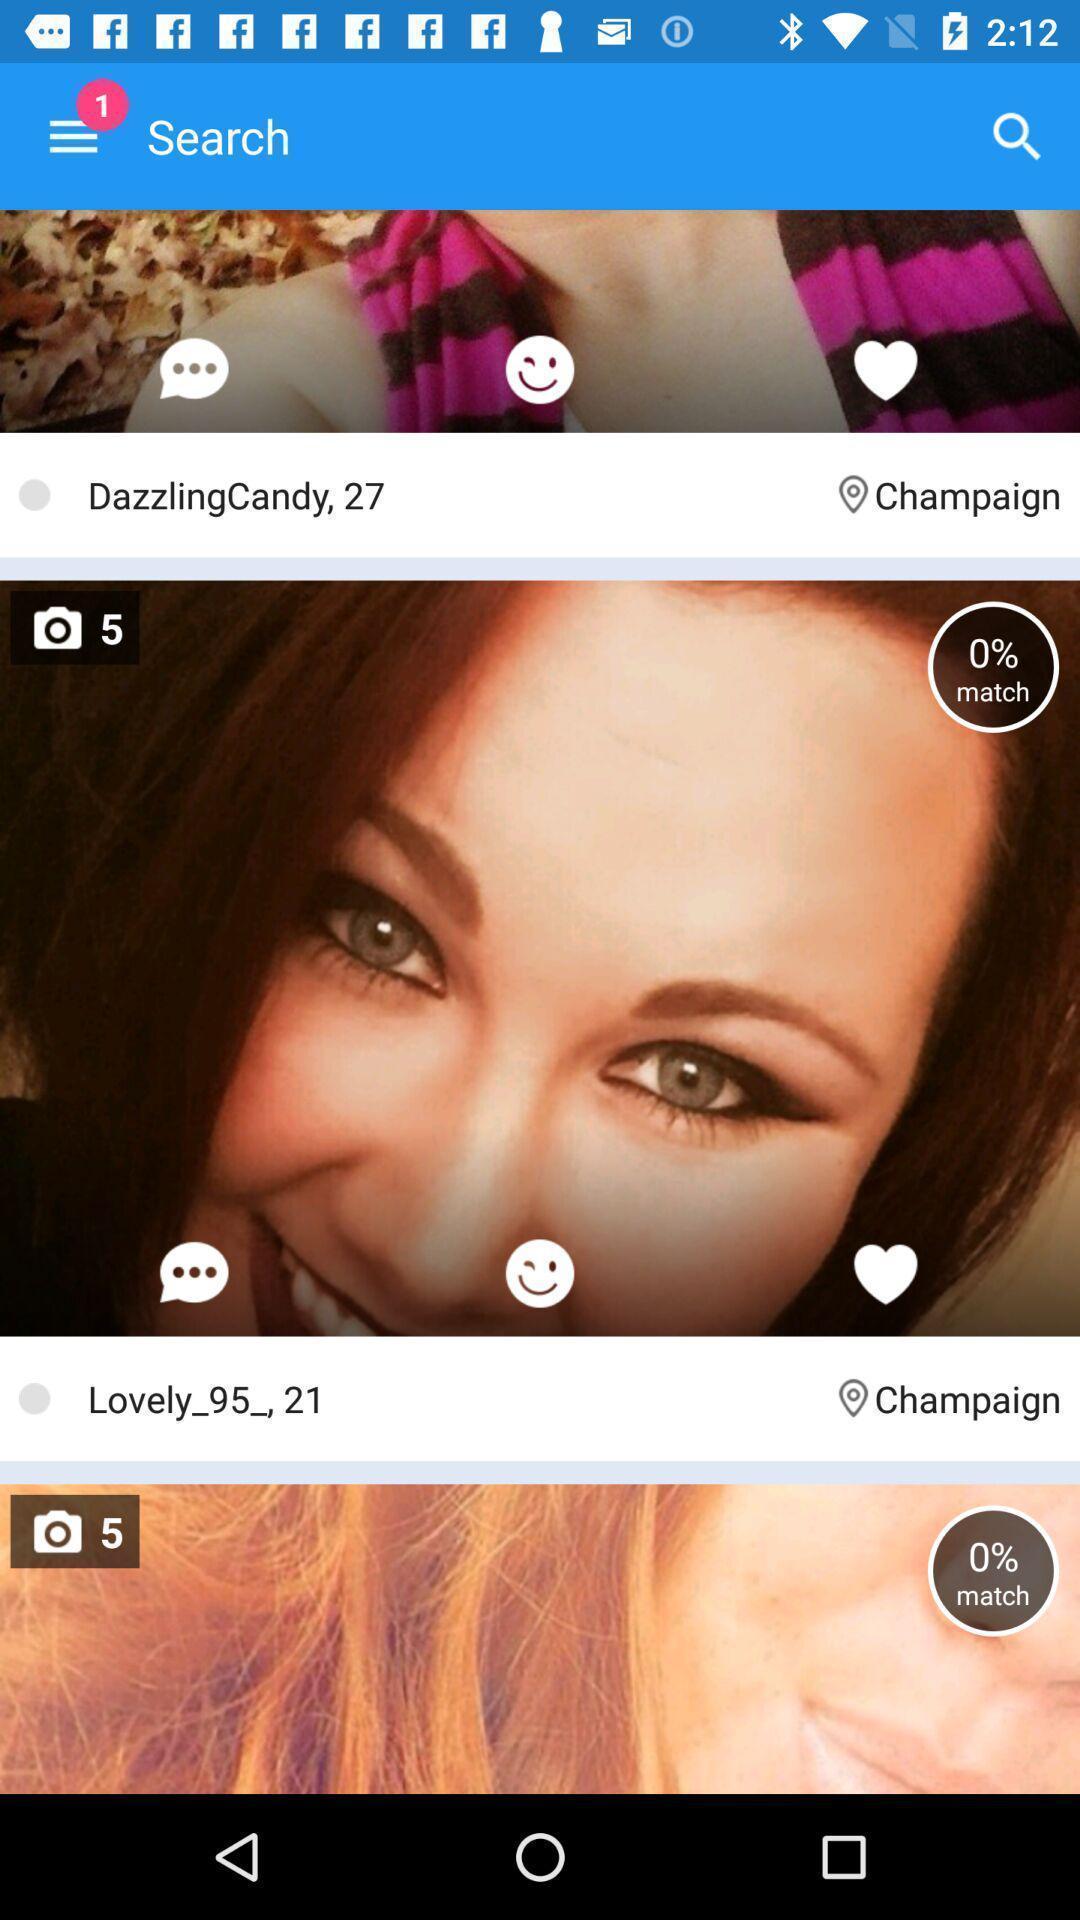Provide a textual representation of this image. Window displaying a dating app. 